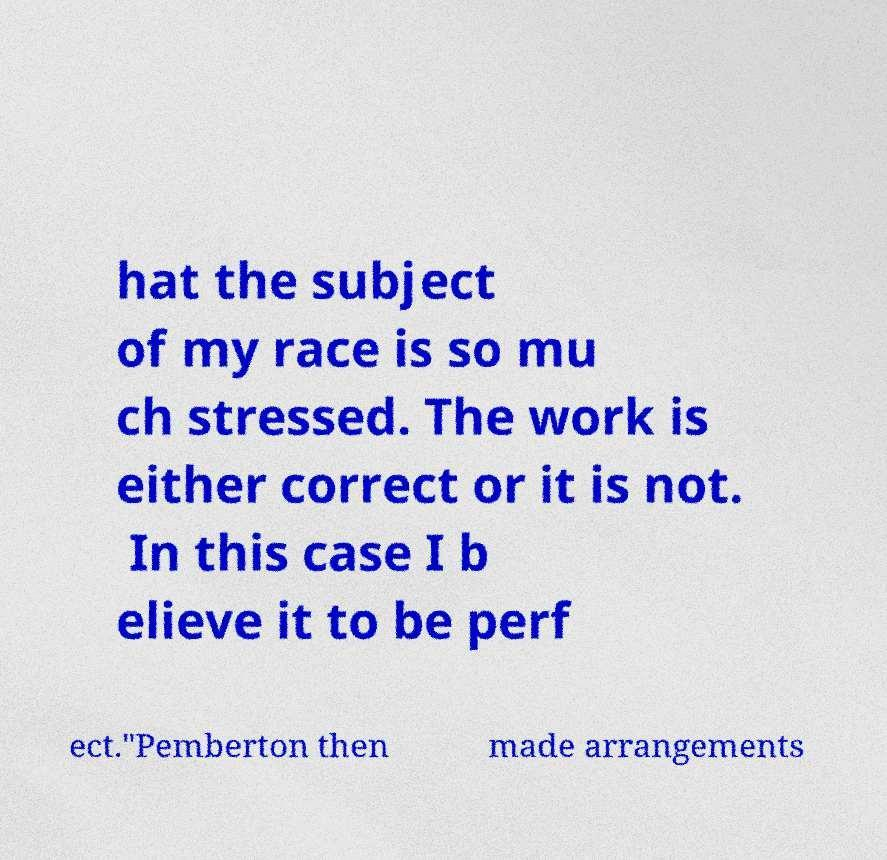Could you extract and type out the text from this image? hat the subject of my race is so mu ch stressed. The work is either correct or it is not. In this case I b elieve it to be perf ect."Pemberton then made arrangements 